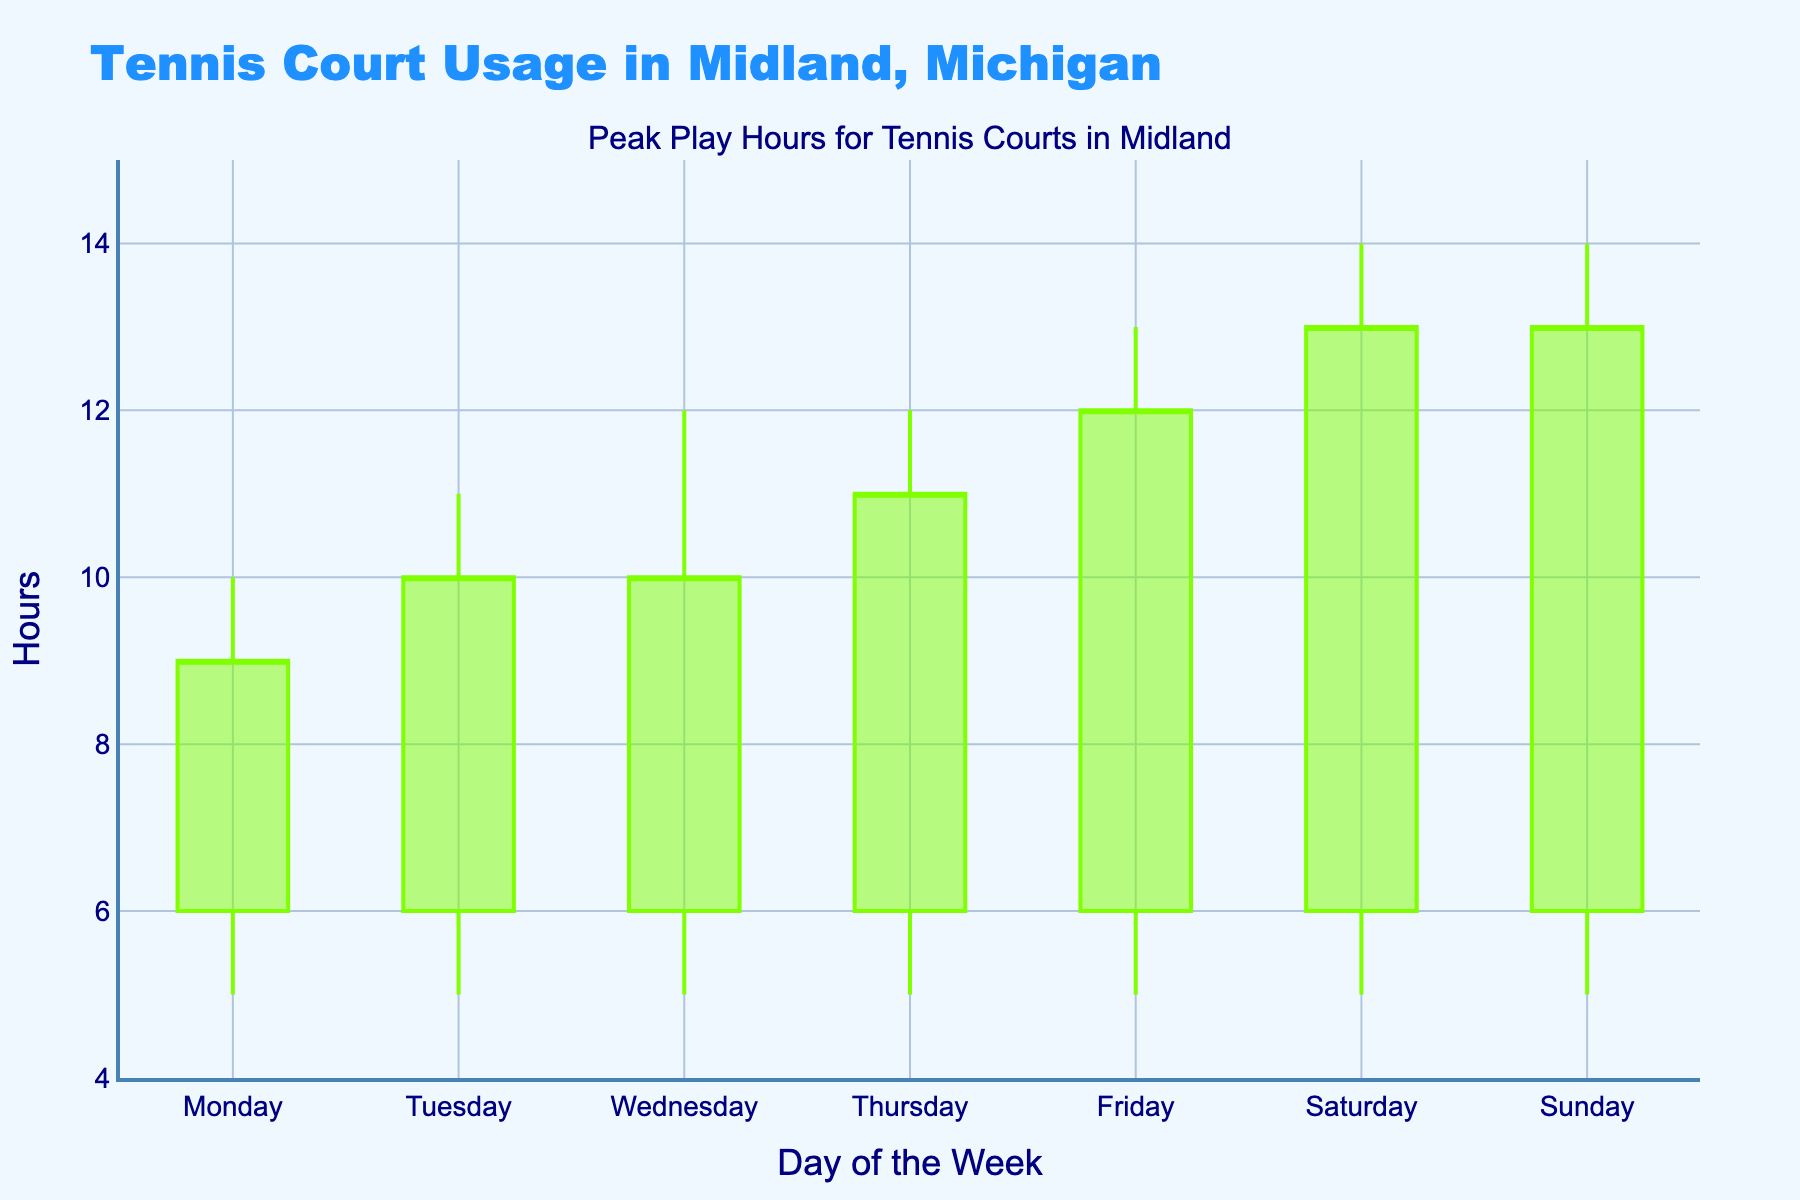What's the title of the candlestick plot? The title is typically found at the top of the plot and gives a summary of what the plot is about. Here, the plot title is "Peak Play Hours for Tennis Courts in Midland"
Answer: Peak Play Hours for Tennis Courts in Midland What days have the highest peak play hours? To find the highest peak play hours, look for the highest points on the plot (the "High" values). On both Saturday and Sunday, the peak play hours are the highest at 14 hours.
Answer: Saturday and Sunday Which days have the courts opening at 6 hours? Inspect the opening values (the lower boundary of the candlestick body on the plot). All candlestick bodies start at 6 hours, indicating the courts open at 6 hours every day of the week.
Answer: All days What is the range of play hours on Wednesday? The range is determined by the highest and lowest points on Wednesday. The high is 12 hours and the low is 5 hours, so the range is 12 - 5 = 7 hours.
Answer: 7 hours How many days have a peak play hour greater than 10? Count the number of candlesticks whose high values (the top of the wick) are greater than 10. These are Wednesday, Thursday, Friday, Saturday, and Sunday (5 days in total).
Answer: 5 days On which day does the court close at 9 hours? The closing value is represented by the upper boundary of the candlestick body. On Monday, the candlestick ends at 9 hours.
Answer: Monday What is the difference between the highest peak play hours and the lowest low play hours across the week? Highest peak play hour is 14 (Sat, Sun). Lowest low play hour is 5 (all days). The difference is 14 - 5 = 9 hours.
Answer: 9 hours Compare the play hours on Tuesday and Thursday. Which day has more variability? Variability can be assessed by looking at the range; Tuesday's range is from 5 to 11 (6 hours), and Thursday's range is from 5 to 12 (7 hours). Thus, Thursday has more variability.
Answer: Thursday What is the average peak play hour of the weekdays (Monday to Friday)? Sum the high values for Monday to Friday and divide by the number of days. (10+11+12+12+13)/5 = 58/5 = 11.6 hours.
Answer: 11.6 hours 